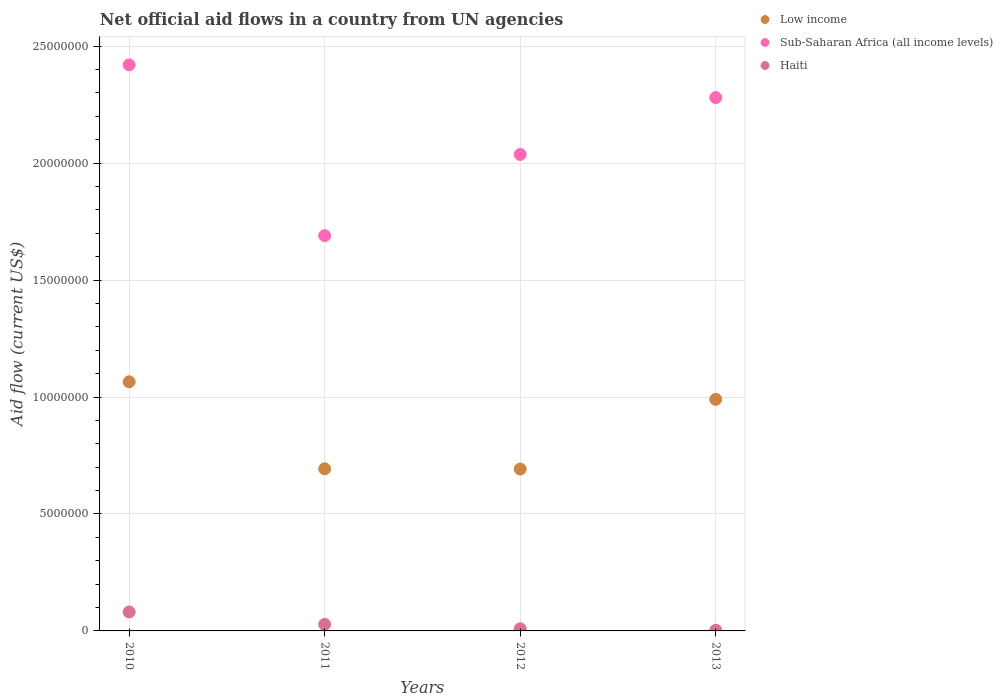How many different coloured dotlines are there?
Your answer should be compact. 3. What is the net official aid flow in Sub-Saharan Africa (all income levels) in 2012?
Provide a succinct answer. 2.04e+07. Across all years, what is the maximum net official aid flow in Haiti?
Your answer should be very brief. 8.10e+05. Across all years, what is the minimum net official aid flow in Low income?
Your answer should be very brief. 6.92e+06. In which year was the net official aid flow in Sub-Saharan Africa (all income levels) minimum?
Your response must be concise. 2011. What is the total net official aid flow in Haiti in the graph?
Keep it short and to the point. 1.21e+06. What is the difference between the net official aid flow in Low income in 2010 and that in 2013?
Your answer should be very brief. 7.50e+05. What is the difference between the net official aid flow in Sub-Saharan Africa (all income levels) in 2012 and the net official aid flow in Haiti in 2010?
Keep it short and to the point. 1.96e+07. What is the average net official aid flow in Sub-Saharan Africa (all income levels) per year?
Your answer should be very brief. 2.11e+07. In the year 2013, what is the difference between the net official aid flow in Haiti and net official aid flow in Sub-Saharan Africa (all income levels)?
Keep it short and to the point. -2.28e+07. In how many years, is the net official aid flow in Haiti greater than 2000000 US$?
Ensure brevity in your answer.  0. What is the ratio of the net official aid flow in Haiti in 2012 to that in 2013?
Make the answer very short. 3. Is the net official aid flow in Sub-Saharan Africa (all income levels) in 2011 less than that in 2013?
Ensure brevity in your answer.  Yes. What is the difference between the highest and the second highest net official aid flow in Low income?
Keep it short and to the point. 7.50e+05. What is the difference between the highest and the lowest net official aid flow in Low income?
Offer a terse response. 3.73e+06. Is the net official aid flow in Haiti strictly greater than the net official aid flow in Low income over the years?
Offer a terse response. No. Is the net official aid flow in Low income strictly less than the net official aid flow in Sub-Saharan Africa (all income levels) over the years?
Provide a succinct answer. Yes. What is the difference between two consecutive major ticks on the Y-axis?
Your response must be concise. 5.00e+06. Does the graph contain any zero values?
Provide a short and direct response. No. Does the graph contain grids?
Your response must be concise. Yes. How are the legend labels stacked?
Ensure brevity in your answer.  Vertical. What is the title of the graph?
Your response must be concise. Net official aid flows in a country from UN agencies. Does "Isle of Man" appear as one of the legend labels in the graph?
Provide a short and direct response. No. What is the label or title of the X-axis?
Your response must be concise. Years. What is the label or title of the Y-axis?
Ensure brevity in your answer.  Aid flow (current US$). What is the Aid flow (current US$) of Low income in 2010?
Make the answer very short. 1.06e+07. What is the Aid flow (current US$) in Sub-Saharan Africa (all income levels) in 2010?
Provide a short and direct response. 2.42e+07. What is the Aid flow (current US$) of Haiti in 2010?
Keep it short and to the point. 8.10e+05. What is the Aid flow (current US$) of Low income in 2011?
Give a very brief answer. 6.93e+06. What is the Aid flow (current US$) of Sub-Saharan Africa (all income levels) in 2011?
Your answer should be very brief. 1.69e+07. What is the Aid flow (current US$) of Haiti in 2011?
Your answer should be compact. 2.80e+05. What is the Aid flow (current US$) of Low income in 2012?
Provide a short and direct response. 6.92e+06. What is the Aid flow (current US$) of Sub-Saharan Africa (all income levels) in 2012?
Your response must be concise. 2.04e+07. What is the Aid flow (current US$) of Haiti in 2012?
Your response must be concise. 9.00e+04. What is the Aid flow (current US$) in Low income in 2013?
Offer a very short reply. 9.90e+06. What is the Aid flow (current US$) in Sub-Saharan Africa (all income levels) in 2013?
Your response must be concise. 2.28e+07. Across all years, what is the maximum Aid flow (current US$) of Low income?
Offer a very short reply. 1.06e+07. Across all years, what is the maximum Aid flow (current US$) of Sub-Saharan Africa (all income levels)?
Your answer should be very brief. 2.42e+07. Across all years, what is the maximum Aid flow (current US$) of Haiti?
Offer a terse response. 8.10e+05. Across all years, what is the minimum Aid flow (current US$) in Low income?
Give a very brief answer. 6.92e+06. Across all years, what is the minimum Aid flow (current US$) of Sub-Saharan Africa (all income levels)?
Ensure brevity in your answer.  1.69e+07. What is the total Aid flow (current US$) in Low income in the graph?
Make the answer very short. 3.44e+07. What is the total Aid flow (current US$) in Sub-Saharan Africa (all income levels) in the graph?
Your response must be concise. 8.43e+07. What is the total Aid flow (current US$) in Haiti in the graph?
Provide a succinct answer. 1.21e+06. What is the difference between the Aid flow (current US$) of Low income in 2010 and that in 2011?
Your response must be concise. 3.72e+06. What is the difference between the Aid flow (current US$) of Sub-Saharan Africa (all income levels) in 2010 and that in 2011?
Make the answer very short. 7.30e+06. What is the difference between the Aid flow (current US$) in Haiti in 2010 and that in 2011?
Your response must be concise. 5.30e+05. What is the difference between the Aid flow (current US$) in Low income in 2010 and that in 2012?
Keep it short and to the point. 3.73e+06. What is the difference between the Aid flow (current US$) of Sub-Saharan Africa (all income levels) in 2010 and that in 2012?
Your answer should be compact. 3.83e+06. What is the difference between the Aid flow (current US$) in Haiti in 2010 and that in 2012?
Your answer should be compact. 7.20e+05. What is the difference between the Aid flow (current US$) of Low income in 2010 and that in 2013?
Your answer should be very brief. 7.50e+05. What is the difference between the Aid flow (current US$) in Sub-Saharan Africa (all income levels) in 2010 and that in 2013?
Provide a succinct answer. 1.40e+06. What is the difference between the Aid flow (current US$) of Haiti in 2010 and that in 2013?
Provide a short and direct response. 7.80e+05. What is the difference between the Aid flow (current US$) of Low income in 2011 and that in 2012?
Offer a terse response. 10000. What is the difference between the Aid flow (current US$) of Sub-Saharan Africa (all income levels) in 2011 and that in 2012?
Give a very brief answer. -3.47e+06. What is the difference between the Aid flow (current US$) in Low income in 2011 and that in 2013?
Your answer should be compact. -2.97e+06. What is the difference between the Aid flow (current US$) of Sub-Saharan Africa (all income levels) in 2011 and that in 2013?
Provide a succinct answer. -5.90e+06. What is the difference between the Aid flow (current US$) in Low income in 2012 and that in 2013?
Keep it short and to the point. -2.98e+06. What is the difference between the Aid flow (current US$) in Sub-Saharan Africa (all income levels) in 2012 and that in 2013?
Provide a succinct answer. -2.43e+06. What is the difference between the Aid flow (current US$) in Low income in 2010 and the Aid flow (current US$) in Sub-Saharan Africa (all income levels) in 2011?
Your answer should be very brief. -6.25e+06. What is the difference between the Aid flow (current US$) in Low income in 2010 and the Aid flow (current US$) in Haiti in 2011?
Provide a succinct answer. 1.04e+07. What is the difference between the Aid flow (current US$) of Sub-Saharan Africa (all income levels) in 2010 and the Aid flow (current US$) of Haiti in 2011?
Provide a short and direct response. 2.39e+07. What is the difference between the Aid flow (current US$) of Low income in 2010 and the Aid flow (current US$) of Sub-Saharan Africa (all income levels) in 2012?
Offer a terse response. -9.72e+06. What is the difference between the Aid flow (current US$) of Low income in 2010 and the Aid flow (current US$) of Haiti in 2012?
Give a very brief answer. 1.06e+07. What is the difference between the Aid flow (current US$) of Sub-Saharan Africa (all income levels) in 2010 and the Aid flow (current US$) of Haiti in 2012?
Give a very brief answer. 2.41e+07. What is the difference between the Aid flow (current US$) of Low income in 2010 and the Aid flow (current US$) of Sub-Saharan Africa (all income levels) in 2013?
Your response must be concise. -1.22e+07. What is the difference between the Aid flow (current US$) of Low income in 2010 and the Aid flow (current US$) of Haiti in 2013?
Make the answer very short. 1.06e+07. What is the difference between the Aid flow (current US$) of Sub-Saharan Africa (all income levels) in 2010 and the Aid flow (current US$) of Haiti in 2013?
Make the answer very short. 2.42e+07. What is the difference between the Aid flow (current US$) in Low income in 2011 and the Aid flow (current US$) in Sub-Saharan Africa (all income levels) in 2012?
Give a very brief answer. -1.34e+07. What is the difference between the Aid flow (current US$) of Low income in 2011 and the Aid flow (current US$) of Haiti in 2012?
Offer a terse response. 6.84e+06. What is the difference between the Aid flow (current US$) of Sub-Saharan Africa (all income levels) in 2011 and the Aid flow (current US$) of Haiti in 2012?
Your answer should be compact. 1.68e+07. What is the difference between the Aid flow (current US$) of Low income in 2011 and the Aid flow (current US$) of Sub-Saharan Africa (all income levels) in 2013?
Give a very brief answer. -1.59e+07. What is the difference between the Aid flow (current US$) of Low income in 2011 and the Aid flow (current US$) of Haiti in 2013?
Your answer should be very brief. 6.90e+06. What is the difference between the Aid flow (current US$) of Sub-Saharan Africa (all income levels) in 2011 and the Aid flow (current US$) of Haiti in 2013?
Offer a terse response. 1.69e+07. What is the difference between the Aid flow (current US$) of Low income in 2012 and the Aid flow (current US$) of Sub-Saharan Africa (all income levels) in 2013?
Offer a very short reply. -1.59e+07. What is the difference between the Aid flow (current US$) of Low income in 2012 and the Aid flow (current US$) of Haiti in 2013?
Give a very brief answer. 6.89e+06. What is the difference between the Aid flow (current US$) in Sub-Saharan Africa (all income levels) in 2012 and the Aid flow (current US$) in Haiti in 2013?
Offer a terse response. 2.03e+07. What is the average Aid flow (current US$) of Low income per year?
Your response must be concise. 8.60e+06. What is the average Aid flow (current US$) in Sub-Saharan Africa (all income levels) per year?
Offer a very short reply. 2.11e+07. What is the average Aid flow (current US$) of Haiti per year?
Your answer should be compact. 3.02e+05. In the year 2010, what is the difference between the Aid flow (current US$) in Low income and Aid flow (current US$) in Sub-Saharan Africa (all income levels)?
Your answer should be very brief. -1.36e+07. In the year 2010, what is the difference between the Aid flow (current US$) of Low income and Aid flow (current US$) of Haiti?
Ensure brevity in your answer.  9.84e+06. In the year 2010, what is the difference between the Aid flow (current US$) of Sub-Saharan Africa (all income levels) and Aid flow (current US$) of Haiti?
Offer a very short reply. 2.34e+07. In the year 2011, what is the difference between the Aid flow (current US$) in Low income and Aid flow (current US$) in Sub-Saharan Africa (all income levels)?
Provide a succinct answer. -9.97e+06. In the year 2011, what is the difference between the Aid flow (current US$) in Low income and Aid flow (current US$) in Haiti?
Your answer should be very brief. 6.65e+06. In the year 2011, what is the difference between the Aid flow (current US$) of Sub-Saharan Africa (all income levels) and Aid flow (current US$) of Haiti?
Give a very brief answer. 1.66e+07. In the year 2012, what is the difference between the Aid flow (current US$) in Low income and Aid flow (current US$) in Sub-Saharan Africa (all income levels)?
Ensure brevity in your answer.  -1.34e+07. In the year 2012, what is the difference between the Aid flow (current US$) of Low income and Aid flow (current US$) of Haiti?
Your answer should be compact. 6.83e+06. In the year 2012, what is the difference between the Aid flow (current US$) in Sub-Saharan Africa (all income levels) and Aid flow (current US$) in Haiti?
Offer a terse response. 2.03e+07. In the year 2013, what is the difference between the Aid flow (current US$) of Low income and Aid flow (current US$) of Sub-Saharan Africa (all income levels)?
Your answer should be very brief. -1.29e+07. In the year 2013, what is the difference between the Aid flow (current US$) in Low income and Aid flow (current US$) in Haiti?
Make the answer very short. 9.87e+06. In the year 2013, what is the difference between the Aid flow (current US$) of Sub-Saharan Africa (all income levels) and Aid flow (current US$) of Haiti?
Give a very brief answer. 2.28e+07. What is the ratio of the Aid flow (current US$) of Low income in 2010 to that in 2011?
Make the answer very short. 1.54. What is the ratio of the Aid flow (current US$) in Sub-Saharan Africa (all income levels) in 2010 to that in 2011?
Make the answer very short. 1.43. What is the ratio of the Aid flow (current US$) of Haiti in 2010 to that in 2011?
Provide a short and direct response. 2.89. What is the ratio of the Aid flow (current US$) of Low income in 2010 to that in 2012?
Provide a short and direct response. 1.54. What is the ratio of the Aid flow (current US$) in Sub-Saharan Africa (all income levels) in 2010 to that in 2012?
Provide a short and direct response. 1.19. What is the ratio of the Aid flow (current US$) in Low income in 2010 to that in 2013?
Give a very brief answer. 1.08. What is the ratio of the Aid flow (current US$) of Sub-Saharan Africa (all income levels) in 2010 to that in 2013?
Provide a short and direct response. 1.06. What is the ratio of the Aid flow (current US$) in Haiti in 2010 to that in 2013?
Make the answer very short. 27. What is the ratio of the Aid flow (current US$) in Sub-Saharan Africa (all income levels) in 2011 to that in 2012?
Make the answer very short. 0.83. What is the ratio of the Aid flow (current US$) in Haiti in 2011 to that in 2012?
Make the answer very short. 3.11. What is the ratio of the Aid flow (current US$) of Sub-Saharan Africa (all income levels) in 2011 to that in 2013?
Your answer should be very brief. 0.74. What is the ratio of the Aid flow (current US$) in Haiti in 2011 to that in 2013?
Your answer should be compact. 9.33. What is the ratio of the Aid flow (current US$) in Low income in 2012 to that in 2013?
Your answer should be compact. 0.7. What is the ratio of the Aid flow (current US$) in Sub-Saharan Africa (all income levels) in 2012 to that in 2013?
Keep it short and to the point. 0.89. What is the difference between the highest and the second highest Aid flow (current US$) in Low income?
Offer a terse response. 7.50e+05. What is the difference between the highest and the second highest Aid flow (current US$) in Sub-Saharan Africa (all income levels)?
Ensure brevity in your answer.  1.40e+06. What is the difference between the highest and the second highest Aid flow (current US$) in Haiti?
Make the answer very short. 5.30e+05. What is the difference between the highest and the lowest Aid flow (current US$) of Low income?
Keep it short and to the point. 3.73e+06. What is the difference between the highest and the lowest Aid flow (current US$) in Sub-Saharan Africa (all income levels)?
Offer a terse response. 7.30e+06. What is the difference between the highest and the lowest Aid flow (current US$) in Haiti?
Your response must be concise. 7.80e+05. 